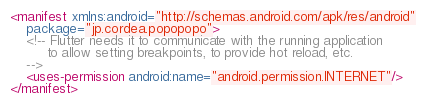Convert code to text. <code><loc_0><loc_0><loc_500><loc_500><_XML_><manifest xmlns:android="http://schemas.android.com/apk/res/android"
    package="jp.cordea.popopopo">
    <!-- Flutter needs it to communicate with the running application
         to allow setting breakpoints, to provide hot reload, etc.
    -->
    <uses-permission android:name="android.permission.INTERNET"/>
</manifest>
</code> 